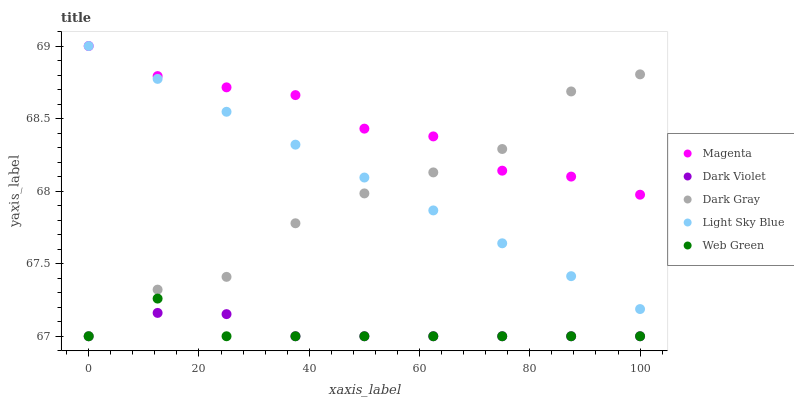Does Web Green have the minimum area under the curve?
Answer yes or no. Yes. Does Magenta have the maximum area under the curve?
Answer yes or no. Yes. Does Light Sky Blue have the minimum area under the curve?
Answer yes or no. No. Does Light Sky Blue have the maximum area under the curve?
Answer yes or no. No. Is Light Sky Blue the smoothest?
Answer yes or no. Yes. Is Dark Gray the roughest?
Answer yes or no. Yes. Is Magenta the smoothest?
Answer yes or no. No. Is Magenta the roughest?
Answer yes or no. No. Does Dark Gray have the lowest value?
Answer yes or no. Yes. Does Light Sky Blue have the lowest value?
Answer yes or no. No. Does Light Sky Blue have the highest value?
Answer yes or no. Yes. Does Web Green have the highest value?
Answer yes or no. No. Is Web Green less than Light Sky Blue?
Answer yes or no. Yes. Is Magenta greater than Web Green?
Answer yes or no. Yes. Does Light Sky Blue intersect Magenta?
Answer yes or no. Yes. Is Light Sky Blue less than Magenta?
Answer yes or no. No. Is Light Sky Blue greater than Magenta?
Answer yes or no. No. Does Web Green intersect Light Sky Blue?
Answer yes or no. No. 